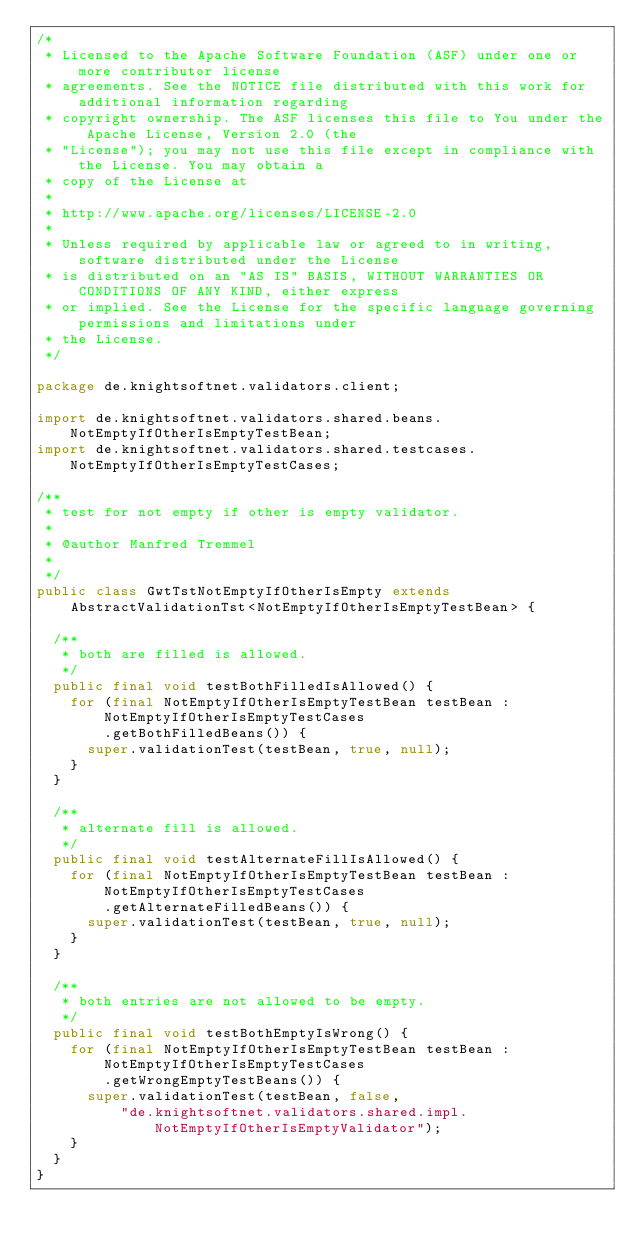Convert code to text. <code><loc_0><loc_0><loc_500><loc_500><_Java_>/*
 * Licensed to the Apache Software Foundation (ASF) under one or more contributor license
 * agreements. See the NOTICE file distributed with this work for additional information regarding
 * copyright ownership. The ASF licenses this file to You under the Apache License, Version 2.0 (the
 * "License"); you may not use this file except in compliance with the License. You may obtain a
 * copy of the License at
 *
 * http://www.apache.org/licenses/LICENSE-2.0
 *
 * Unless required by applicable law or agreed to in writing, software distributed under the License
 * is distributed on an "AS IS" BASIS, WITHOUT WARRANTIES OR CONDITIONS OF ANY KIND, either express
 * or implied. See the License for the specific language governing permissions and limitations under
 * the License.
 */

package de.knightsoftnet.validators.client;

import de.knightsoftnet.validators.shared.beans.NotEmptyIfOtherIsEmptyTestBean;
import de.knightsoftnet.validators.shared.testcases.NotEmptyIfOtherIsEmptyTestCases;

/**
 * test for not empty if other is empty validator.
 *
 * @author Manfred Tremmel
 *
 */
public class GwtTstNotEmptyIfOtherIsEmpty extends
    AbstractValidationTst<NotEmptyIfOtherIsEmptyTestBean> {

  /**
   * both are filled is allowed.
   */
  public final void testBothFilledIsAllowed() {
    for (final NotEmptyIfOtherIsEmptyTestBean testBean : NotEmptyIfOtherIsEmptyTestCases
        .getBothFilledBeans()) {
      super.validationTest(testBean, true, null);
    }
  }

  /**
   * alternate fill is allowed.
   */
  public final void testAlternateFillIsAllowed() {
    for (final NotEmptyIfOtherIsEmptyTestBean testBean : NotEmptyIfOtherIsEmptyTestCases
        .getAlternateFilledBeans()) {
      super.validationTest(testBean, true, null);
    }
  }

  /**
   * both entries are not allowed to be empty.
   */
  public final void testBothEmptyIsWrong() {
    for (final NotEmptyIfOtherIsEmptyTestBean testBean : NotEmptyIfOtherIsEmptyTestCases
        .getWrongEmptyTestBeans()) {
      super.validationTest(testBean, false,
          "de.knightsoftnet.validators.shared.impl.NotEmptyIfOtherIsEmptyValidator");
    }
  }
}
</code> 